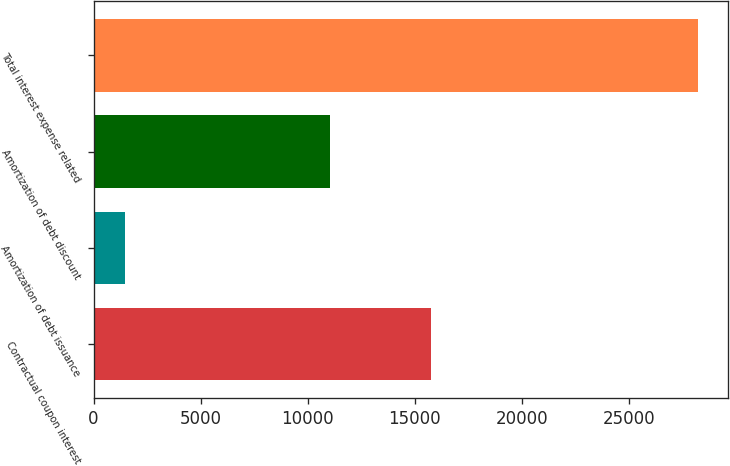<chart> <loc_0><loc_0><loc_500><loc_500><bar_chart><fcel>Contractual coupon interest<fcel>Amortization of debt issuance<fcel>Amortization of debt discount<fcel>Total interest expense related<nl><fcel>15750<fcel>1448<fcel>11052<fcel>28250<nl></chart> 